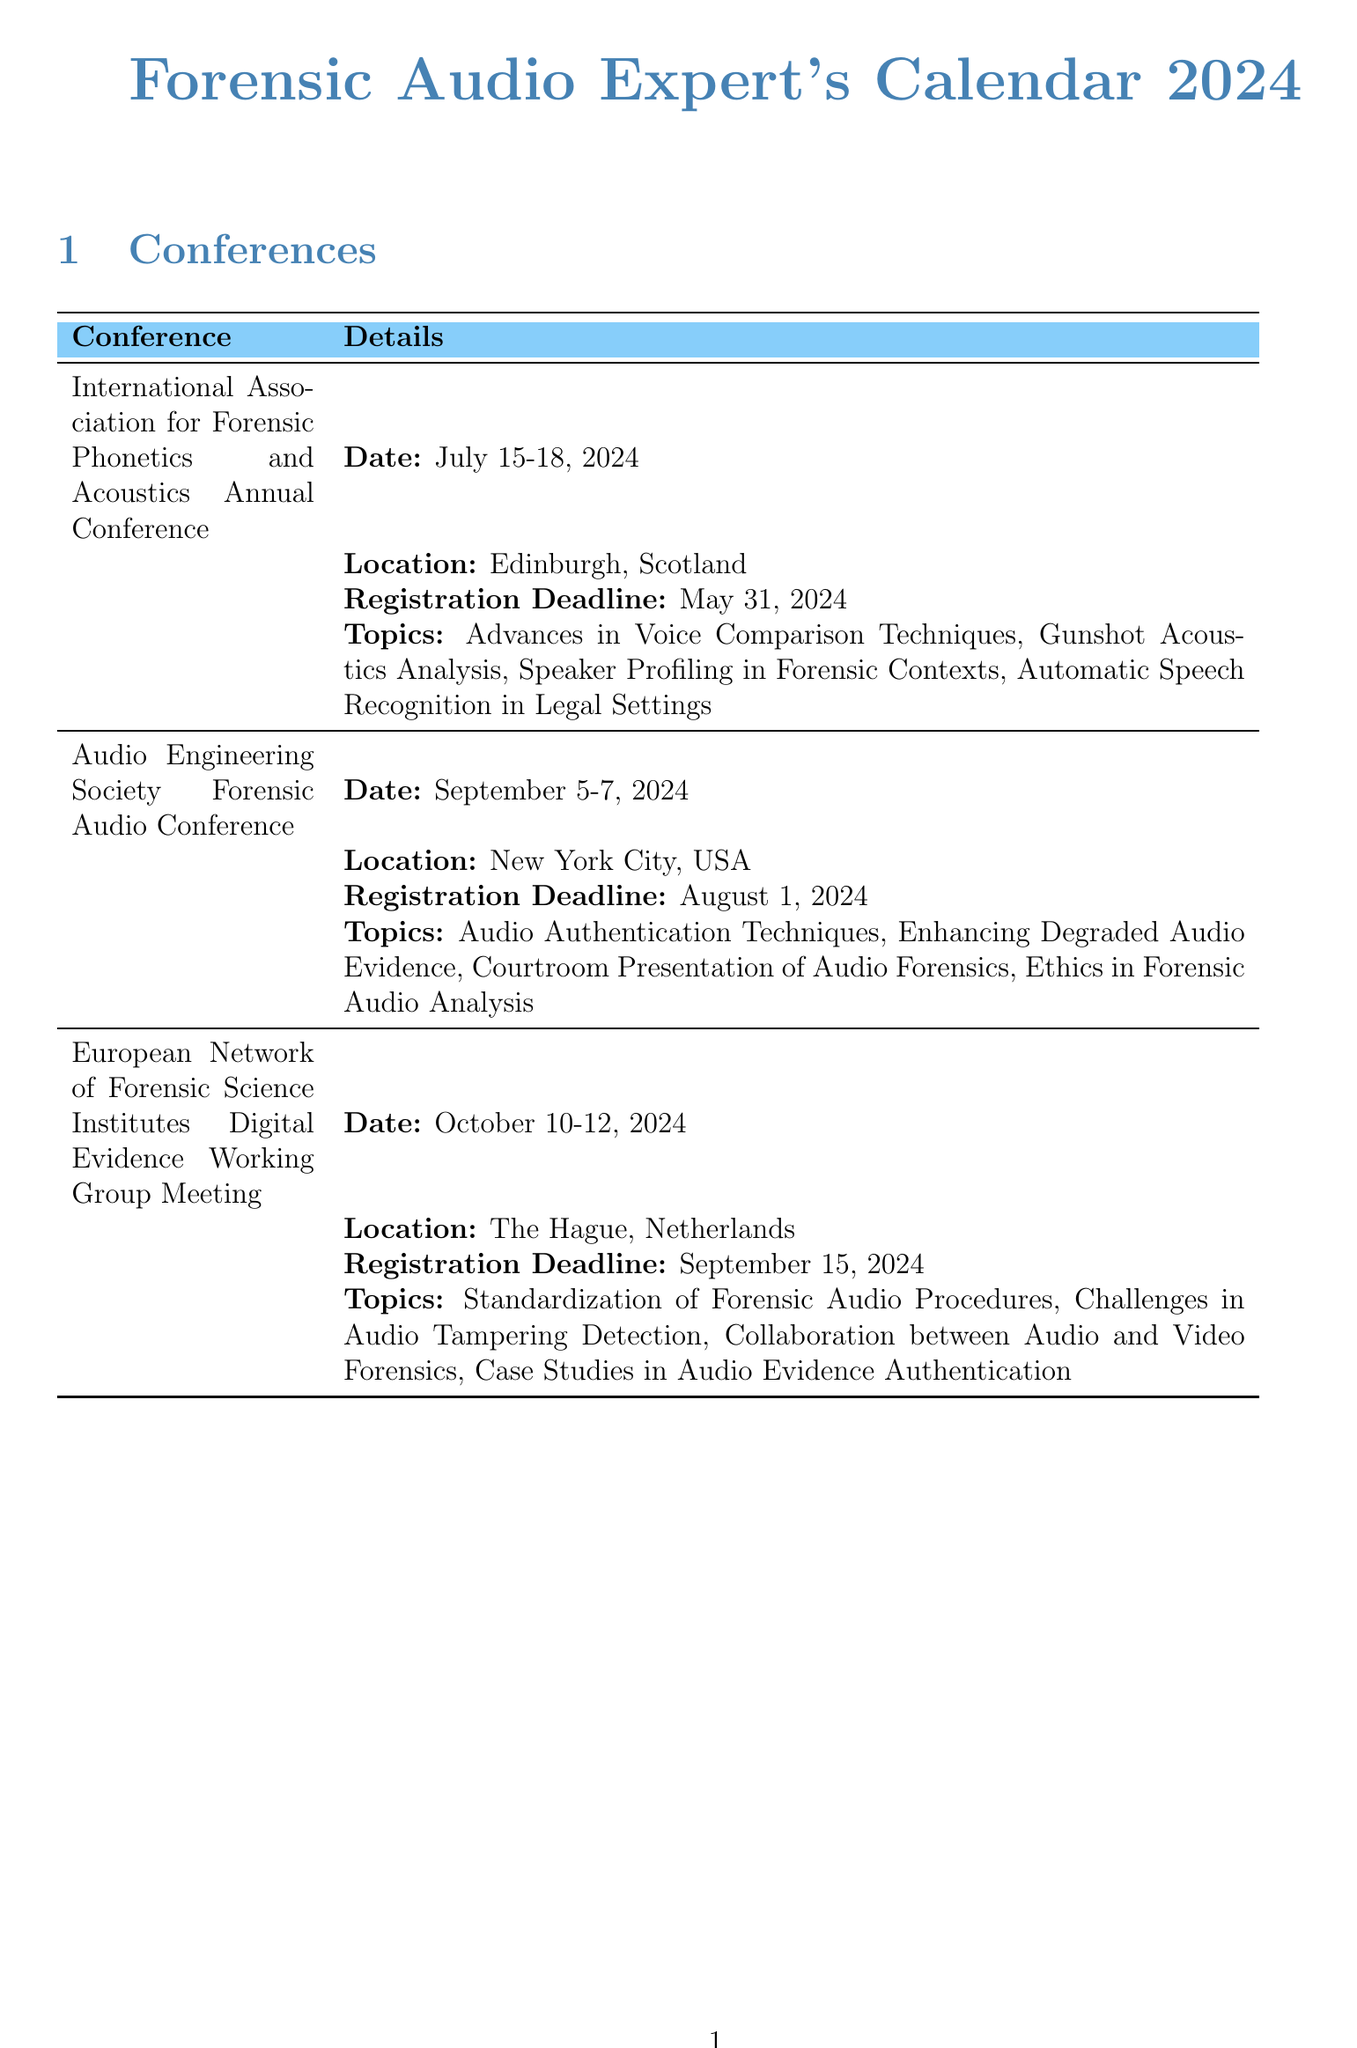What are the dates for the International Association for Forensic Phonetics and Acoustics Annual Conference? The dates are listed in the document as July 15-18, 2024.
Answer: July 15-18, 2024 Where is the Audio Engineering Society Forensic Audio Conference being held? The location is stated in the document as New York City, USA.
Answer: New York City, USA What is the registration deadline for the Sandoval Forensic Audio Analysis Workshop? The document specifies the registration deadline as April 15, 2024.
Answer: April 15, 2024 How many topics are listed for the European Network of Forensic Science Institutes Digital Evidence Working Group Meeting? The number of topics can be counted from the document as there are four topics listed.
Answer: Four Which workshop focuses on Courtroom Testimony for Audio Experts? By examining the topics, the FBI Forensic Audio, Video, and Image Analysis Unit Training includes this focus.
Answer: FBI Forensic Audio, Video, and Image Analysis Unit Training When is the registration deadline for the Australian Federal Police Digital Forensics Symposium? The document indicates the deadline as October 1, 2024.
Answer: October 1, 2024 What is one topic that will be presented at the International Association for Forensic Phonetics and Acoustics Annual Conference? The document lists multiple presentation topics, one of which is Advances in Voice Comparison Techniques.
Answer: Advances in Voice Comparison Techniques What is the location of the FBI Forensic Audio, Video, and Image Analysis Unit Training workshop? The document specifies Quantico, Virginia, USA as the location for this workshop.
Answer: Quantico, Virginia, USA What conference occurs closest to the end of the year? By looking at the dates, the Australian Federal Police Digital Forensics Symposium in November is the last in the year.
Answer: Australian Federal Police Digital Forensics Symposium 